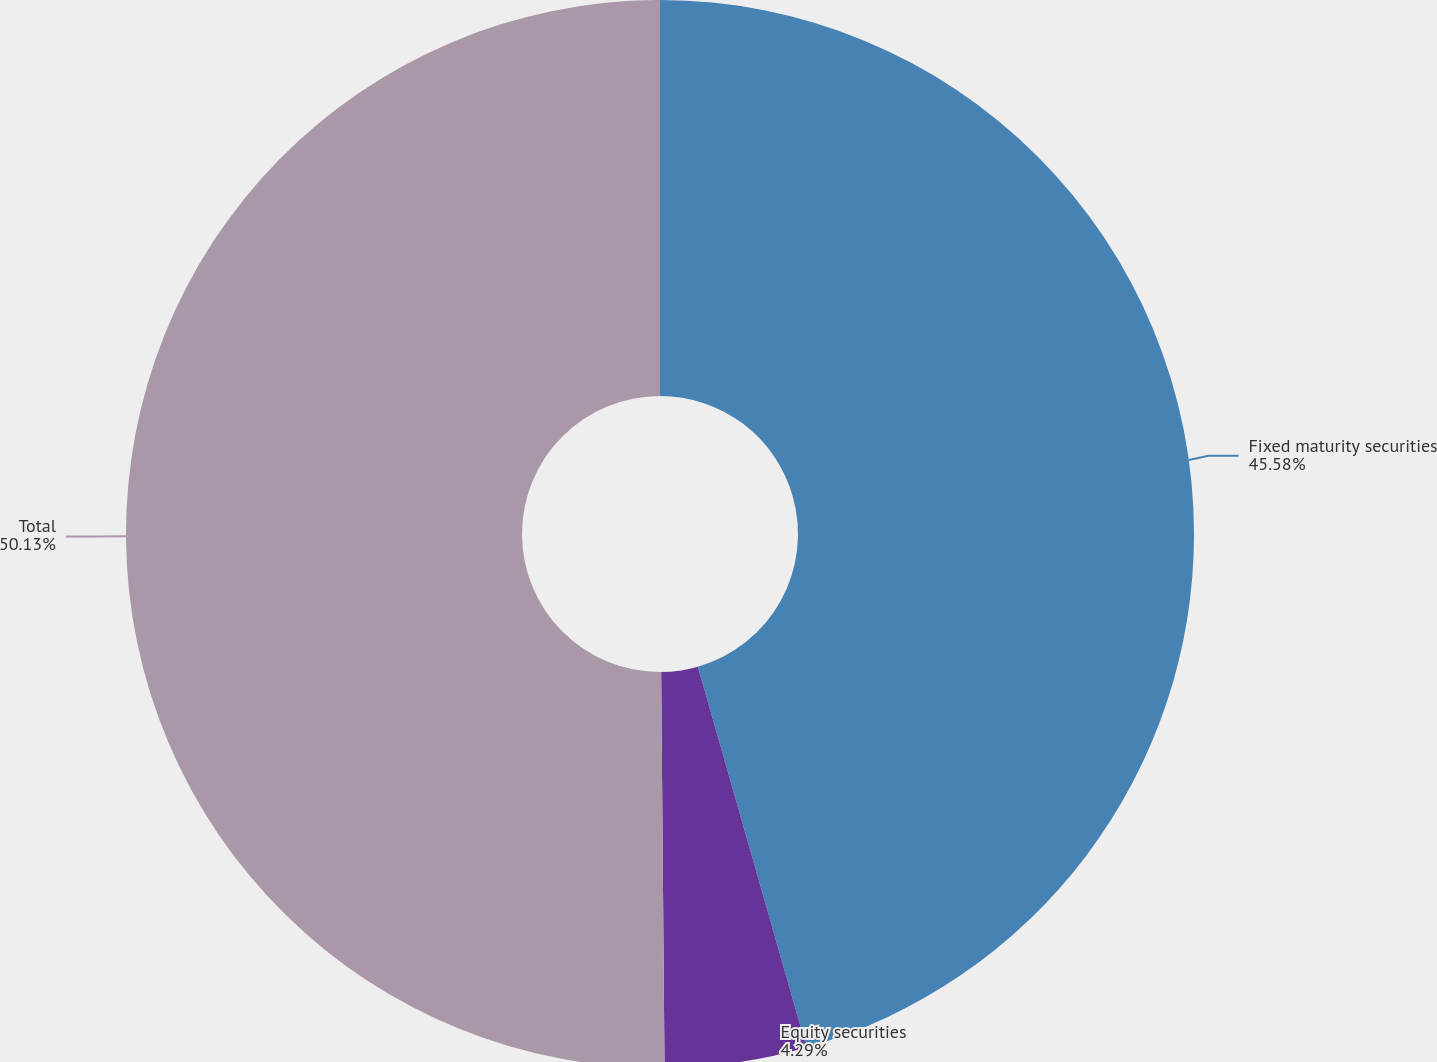Convert chart. <chart><loc_0><loc_0><loc_500><loc_500><pie_chart><fcel>Fixed maturity securities<fcel>Equity securities<fcel>Total<nl><fcel>45.58%<fcel>4.29%<fcel>50.14%<nl></chart> 